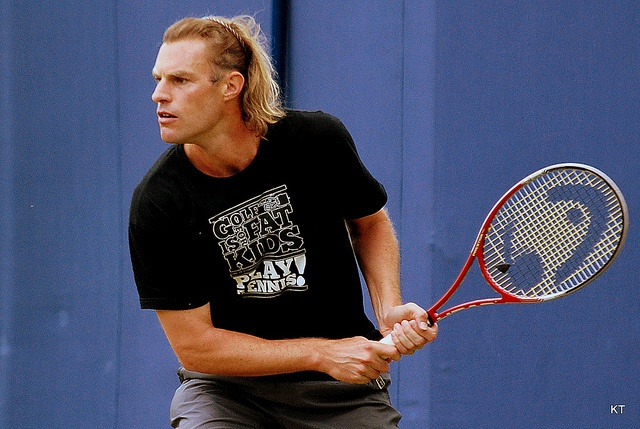Describe the objects in this image and their specific colors. I can see people in blue, black, brown, maroon, and salmon tones and tennis racket in blue, gray, lightgray, and darkblue tones in this image. 